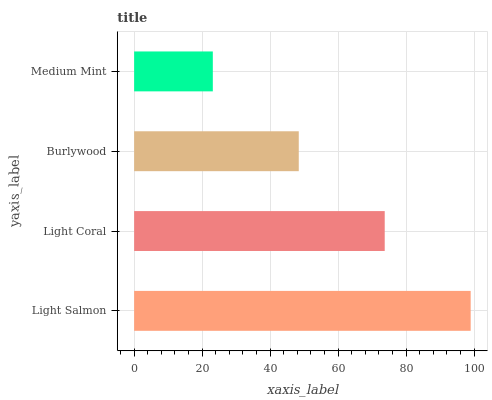Is Medium Mint the minimum?
Answer yes or no. Yes. Is Light Salmon the maximum?
Answer yes or no. Yes. Is Light Coral the minimum?
Answer yes or no. No. Is Light Coral the maximum?
Answer yes or no. No. Is Light Salmon greater than Light Coral?
Answer yes or no. Yes. Is Light Coral less than Light Salmon?
Answer yes or no. Yes. Is Light Coral greater than Light Salmon?
Answer yes or no. No. Is Light Salmon less than Light Coral?
Answer yes or no. No. Is Light Coral the high median?
Answer yes or no. Yes. Is Burlywood the low median?
Answer yes or no. Yes. Is Burlywood the high median?
Answer yes or no. No. Is Light Coral the low median?
Answer yes or no. No. 